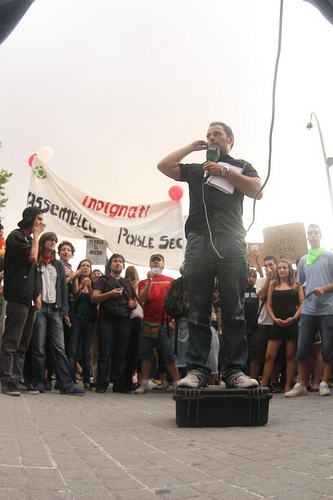<image>
Is the man on the box? No. The man is not positioned on the box. They may be near each other, but the man is not supported by or resting on top of the box. Is there a crowd under the man? No. The crowd is not positioned under the man. The vertical relationship between these objects is different. Is the speaker to the right of the man? Yes. From this viewpoint, the speaker is positioned to the right side relative to the man. 